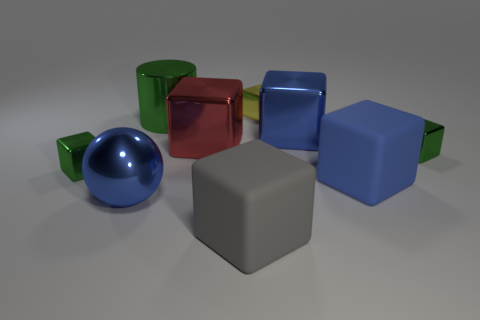What is the color of the shiny cylinder?
Make the answer very short. Green. Do the big metallic ball and the rubber object that is behind the big blue ball have the same color?
Offer a terse response. Yes. There is a sphere that is made of the same material as the red cube; what is its size?
Provide a short and direct response. Large. Are there any tiny blocks that have the same color as the cylinder?
Offer a terse response. Yes. What number of things are blue blocks behind the red block or big metal cylinders?
Your response must be concise. 2. Do the big gray object and the blue object that is to the left of the yellow metal cube have the same material?
Provide a succinct answer. No. There is a metal thing that is the same color as the big metallic ball; what size is it?
Your answer should be very brief. Large. Are there any other green objects made of the same material as the large green object?
Your response must be concise. Yes. How many things are either tiny shiny objects that are in front of the small yellow shiny block or large cubes on the right side of the yellow metal object?
Provide a short and direct response. 4. There is a big gray thing; is its shape the same as the big blue shiny thing on the right side of the large blue metallic sphere?
Your answer should be very brief. Yes. 